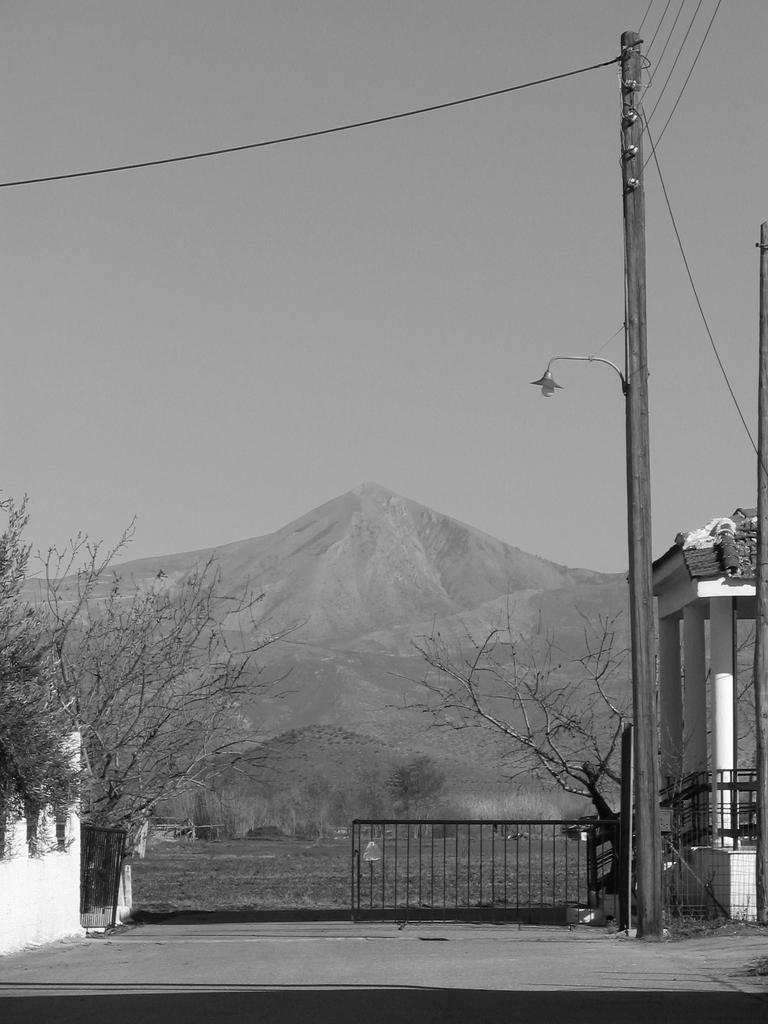How would you summarize this image in a sentence or two? In the image we can see an electric pole, light and electric wires. We can even see there are trees, fence, pillars, mountain and a sky. 